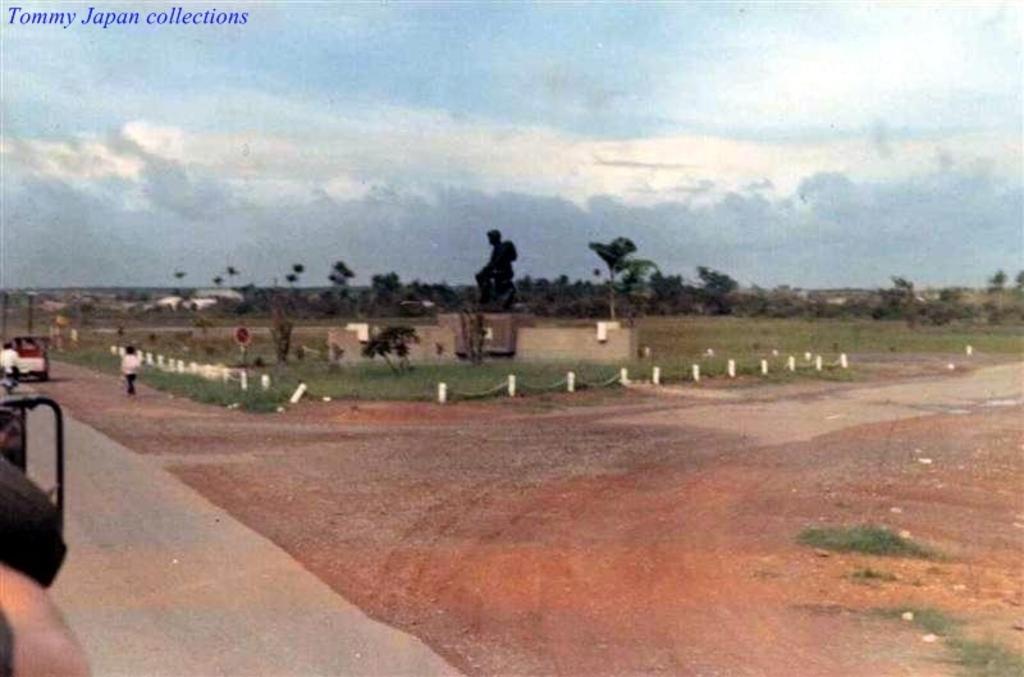Please provide a concise description of this image. In the picture we can see a photograph of a road and beside it we can see a grass surface and around it we can see a fencing stones and near to it we can see a person standing and in the background we can see trees, and sky with clouds. 